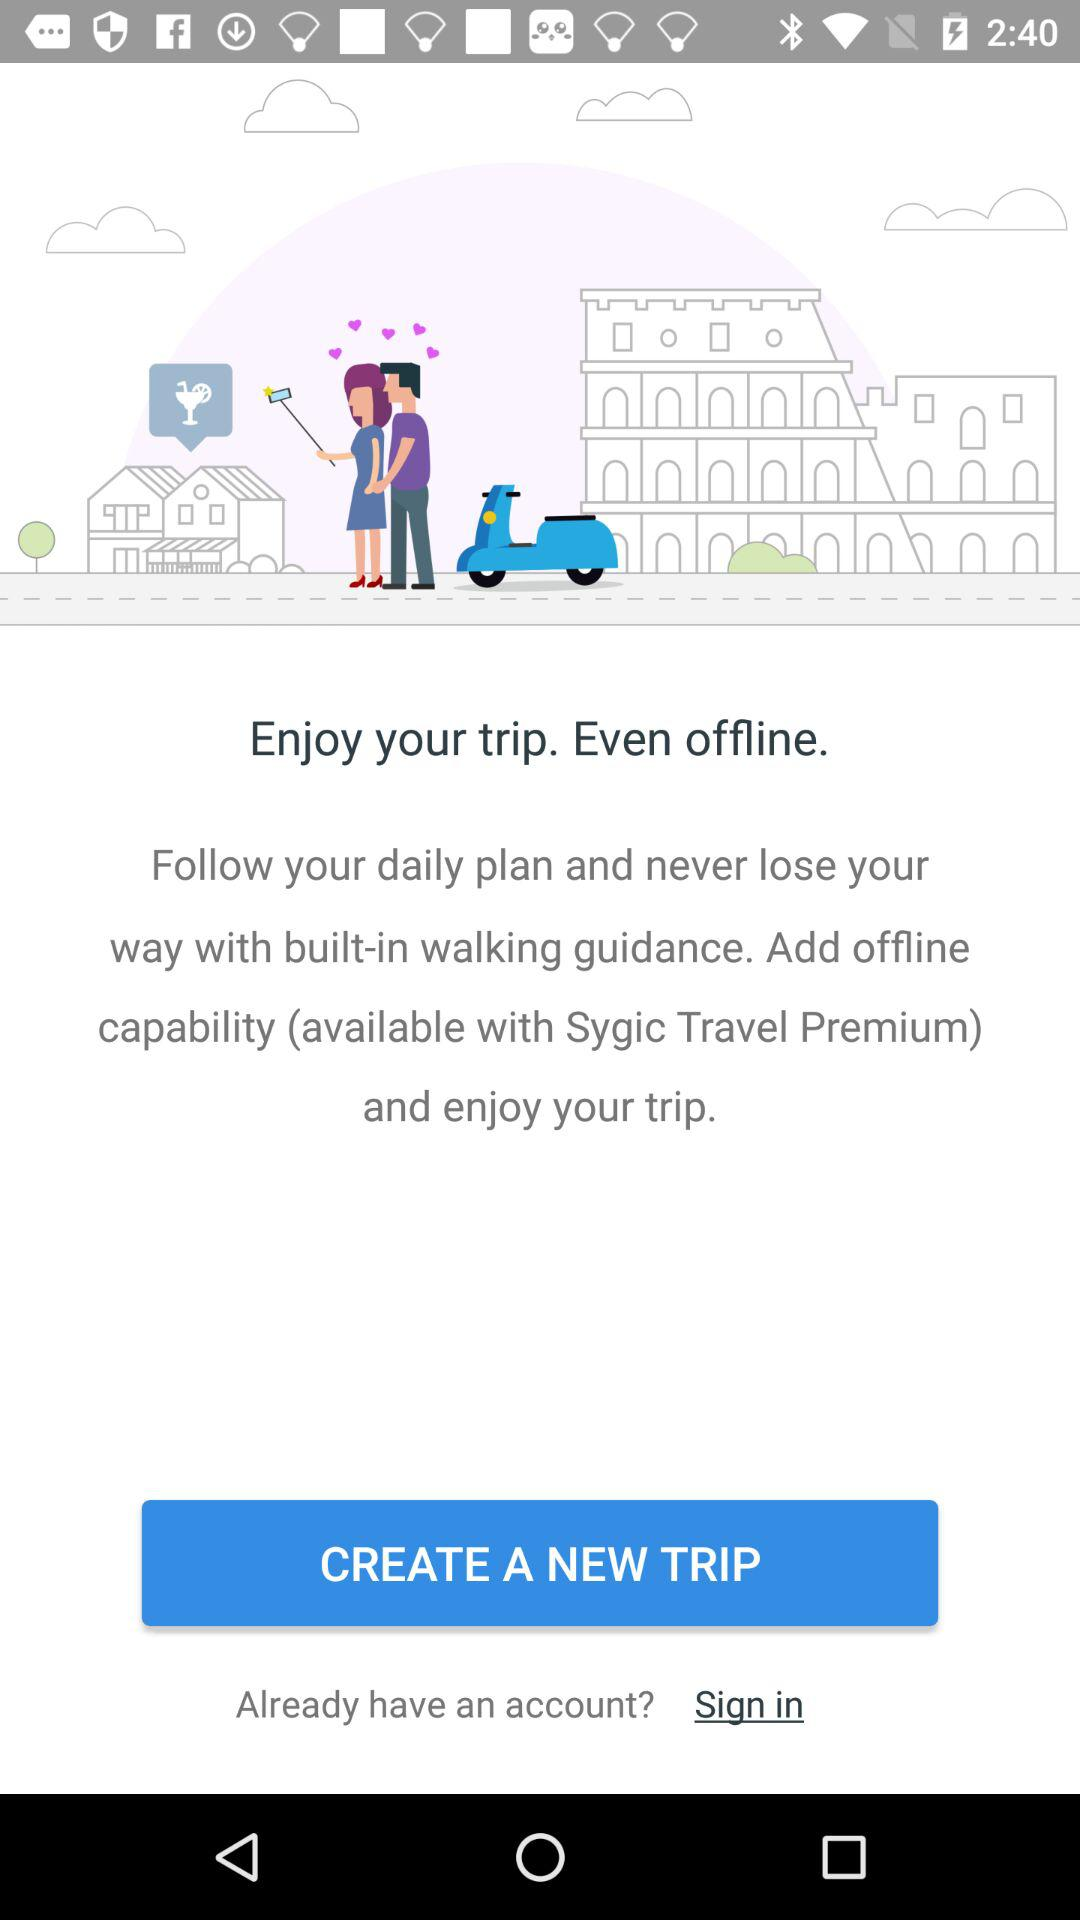How can I enjoy my trip? You can enjoy your trip by "Follow your daily plan and never lose your way with built-in walking guidance. Add offline capability (available with Sygic Travel Premium) and enjoy your trip". 